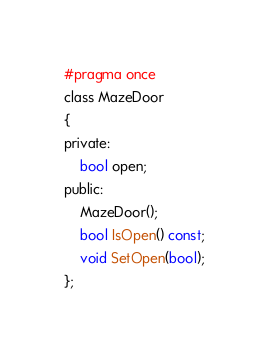<code> <loc_0><loc_0><loc_500><loc_500><_C_>#pragma once
class MazeDoor
{
private:
	bool open;
public:
	MazeDoor();
	bool IsOpen() const;
	void SetOpen(bool);
};</code> 